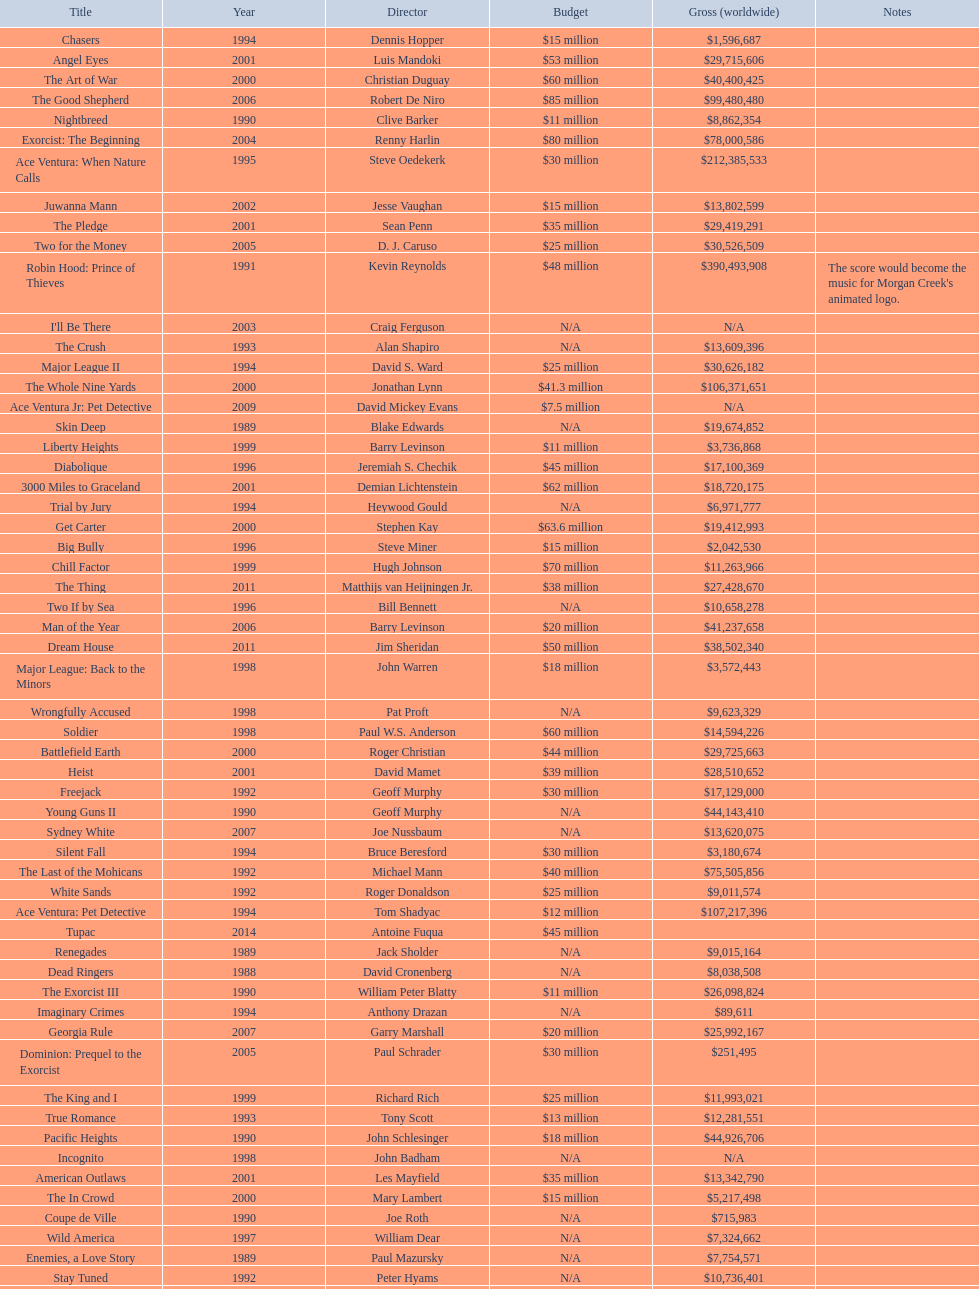How many films were there in 1990? 5. 